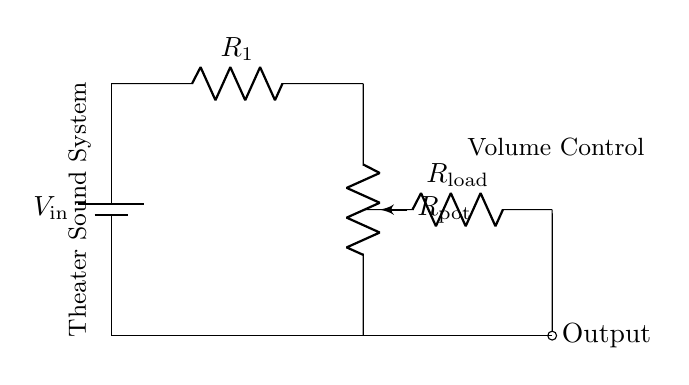What is the function of R1 in this circuit? R1 serves as a fixed resistance in the voltage divider that helps set the overall resistance of the circuit. It works in conjunction with the potentiometer to control the voltage output.
Answer: Fixed resistance What component controls the volume in the sound system? The component that controls the volume is the potentiometer, which can vary its resistance to change the output voltage.
Answer: Potentiometer What is the output of this circuit represented as? The output is represented as the voltage across the load resistor, which is connected to the output terminal at the end of the circuit.
Answer: Output voltage How many resistors are present in this circuit? There are three resistors present: R1, the potentiometer (Rpot), and the load resistor (Rload).
Answer: Three What type of circuit is this? This is a voltage divider circuit, designed to divide the input voltage into a lower output voltage based on the ratio of resistances.
Answer: Voltage divider How does changing the potentiometer affect the output voltage? Altering the potentiometer changes its resistance, which in turn alters the voltage ratio between R1 and Rpot, effectively adjusting the output voltage based on the desired volume level.
Answer: Adjusts output voltage What is the role of the load resistor in this circuit? The load resistor is the component that consumes the output voltage, representing the actual load connected to the theater sound system, affecting the overall output based on its resistance value.
Answer: Consumes output voltage 